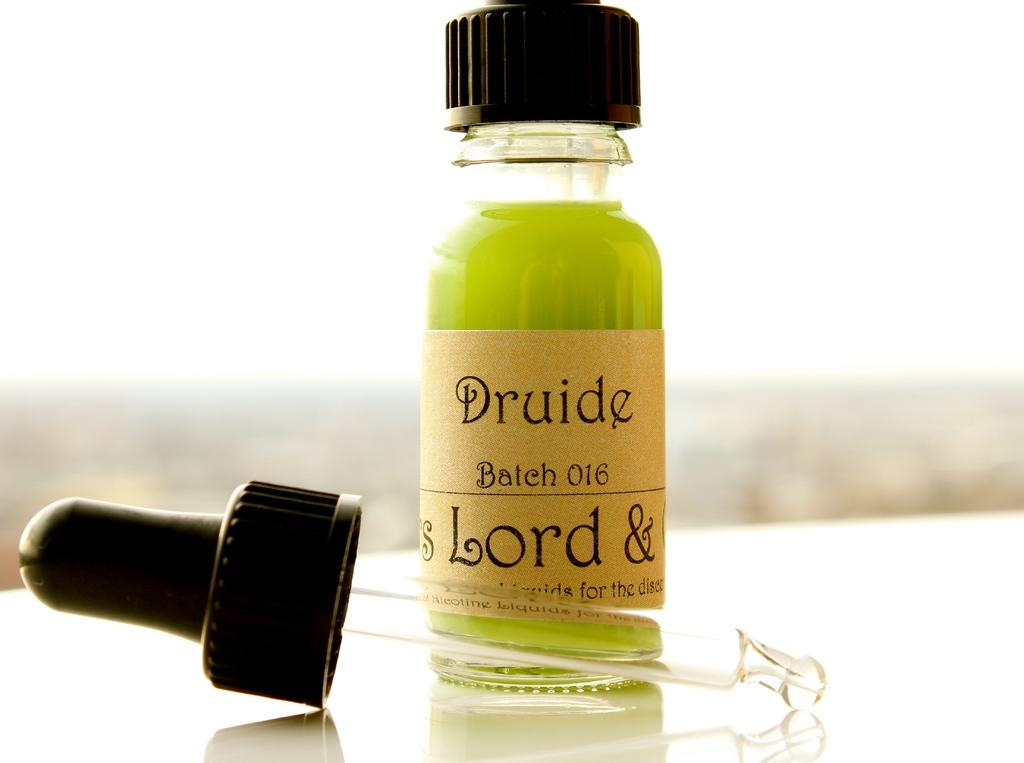<image>
Give a short and clear explanation of the subsequent image. a tube of liquid with the word Druide on it 